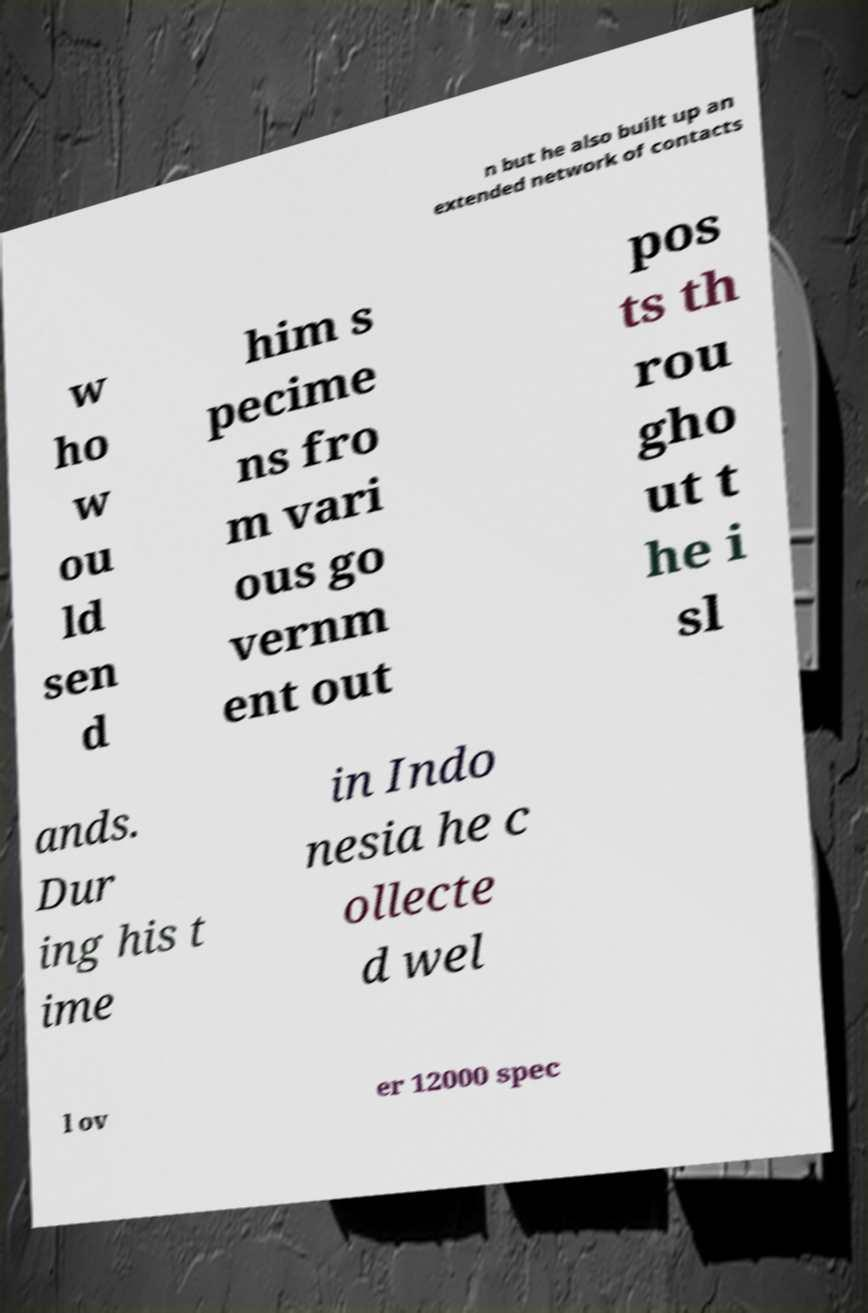Please identify and transcribe the text found in this image. n but he also built up an extended network of contacts w ho w ou ld sen d him s pecime ns fro m vari ous go vernm ent out pos ts th rou gho ut t he i sl ands. Dur ing his t ime in Indo nesia he c ollecte d wel l ov er 12000 spec 